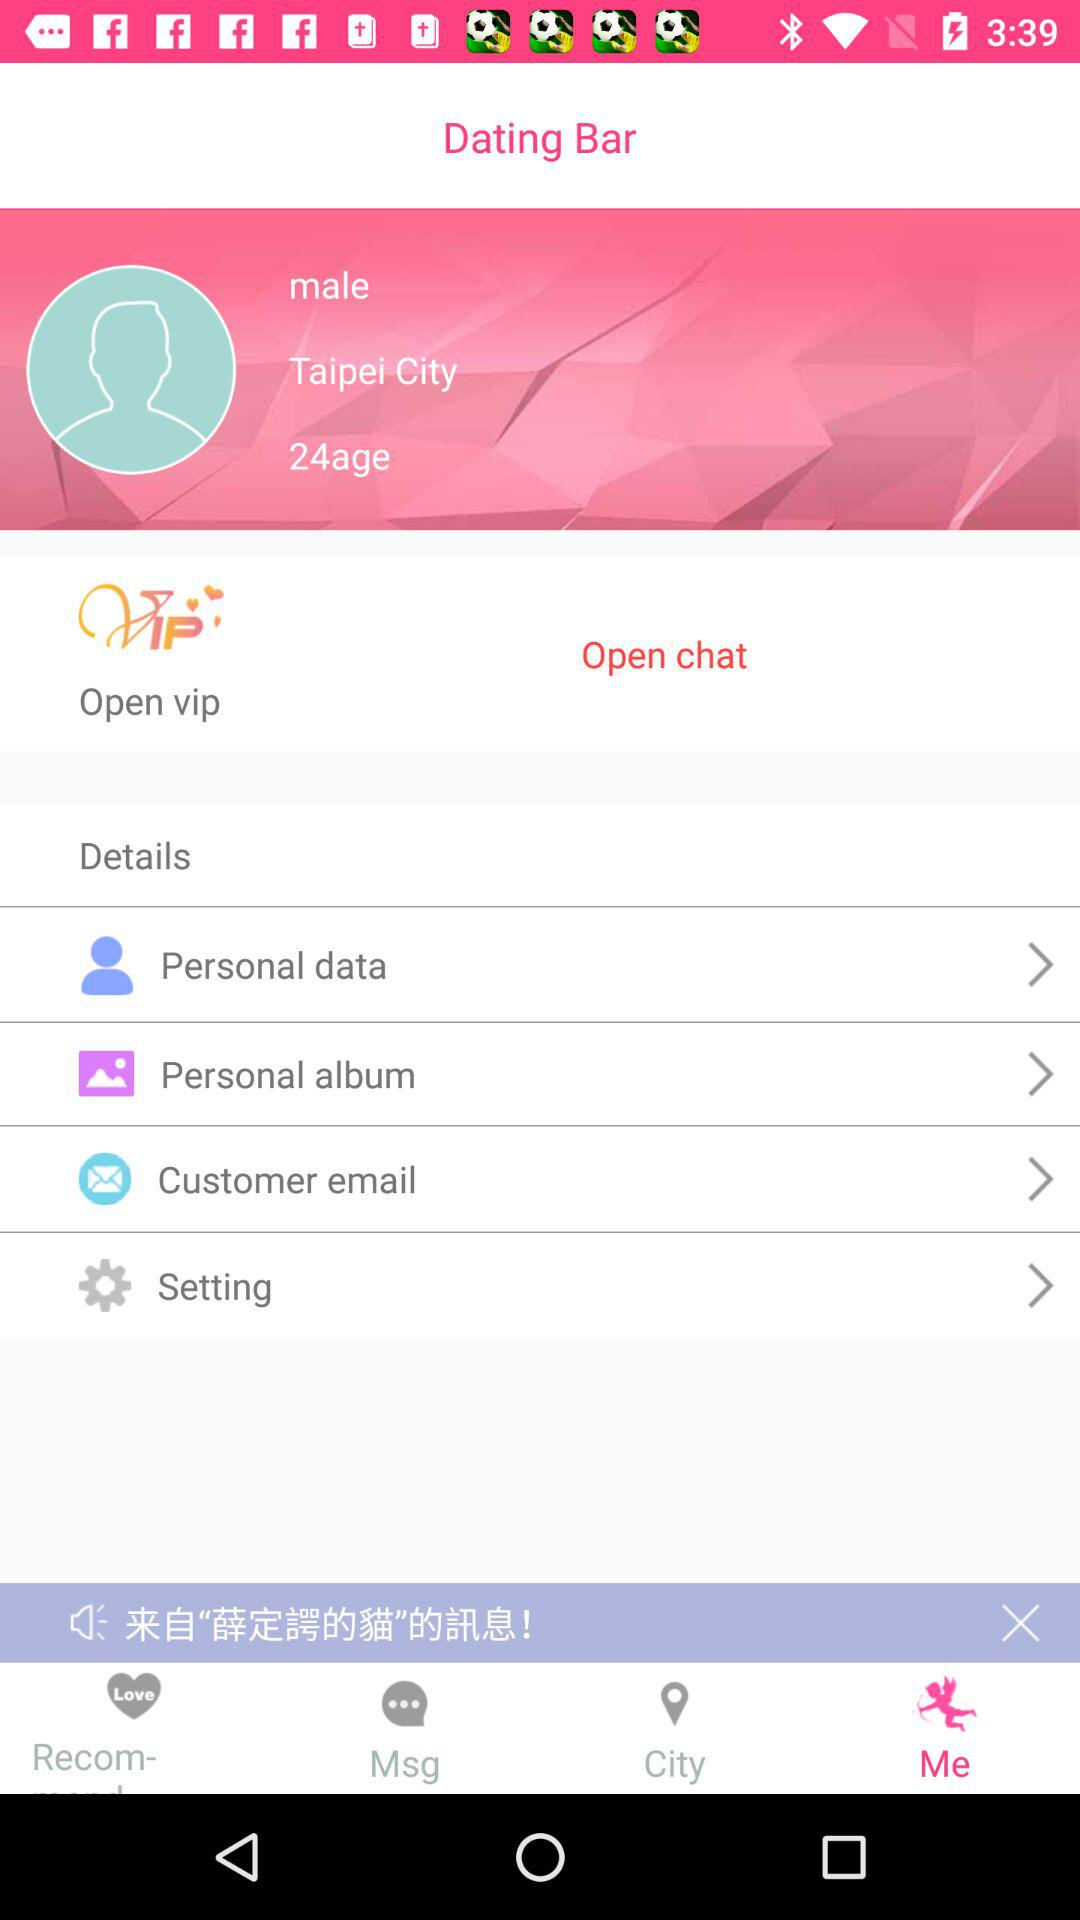What is the gender of the user? The gender of the user is male. 